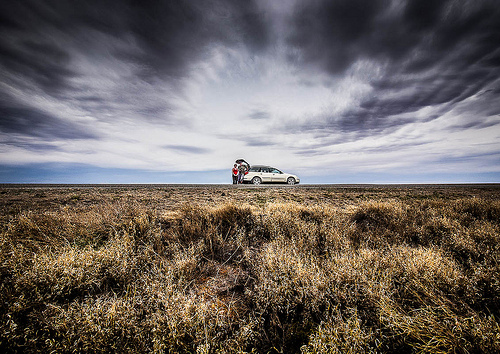<image>
Is the sky behind the road? Yes. From this viewpoint, the sky is positioned behind the road, with the road partially or fully occluding the sky. Where is the cloud in relation to the grass? Is it in front of the grass? No. The cloud is not in front of the grass. The spatial positioning shows a different relationship between these objects. 